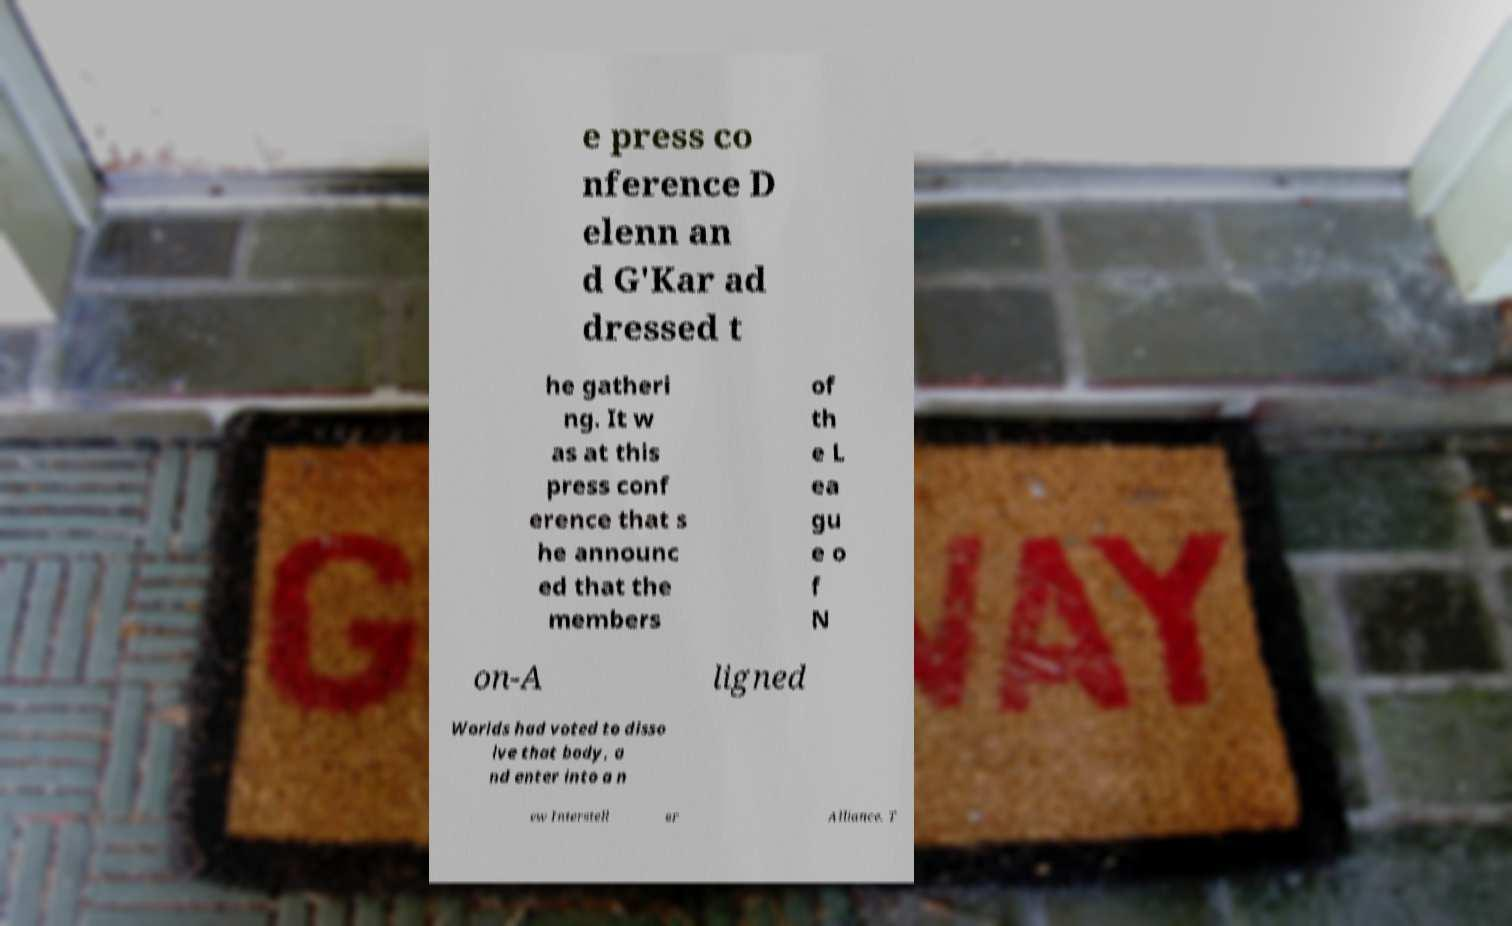Please read and relay the text visible in this image. What does it say? e press co nference D elenn an d G'Kar ad dressed t he gatheri ng. It w as at this press conf erence that s he announc ed that the members of th e L ea gu e o f N on-A ligned Worlds had voted to disso lve that body, a nd enter into a n ew Interstell ar Alliance. T 